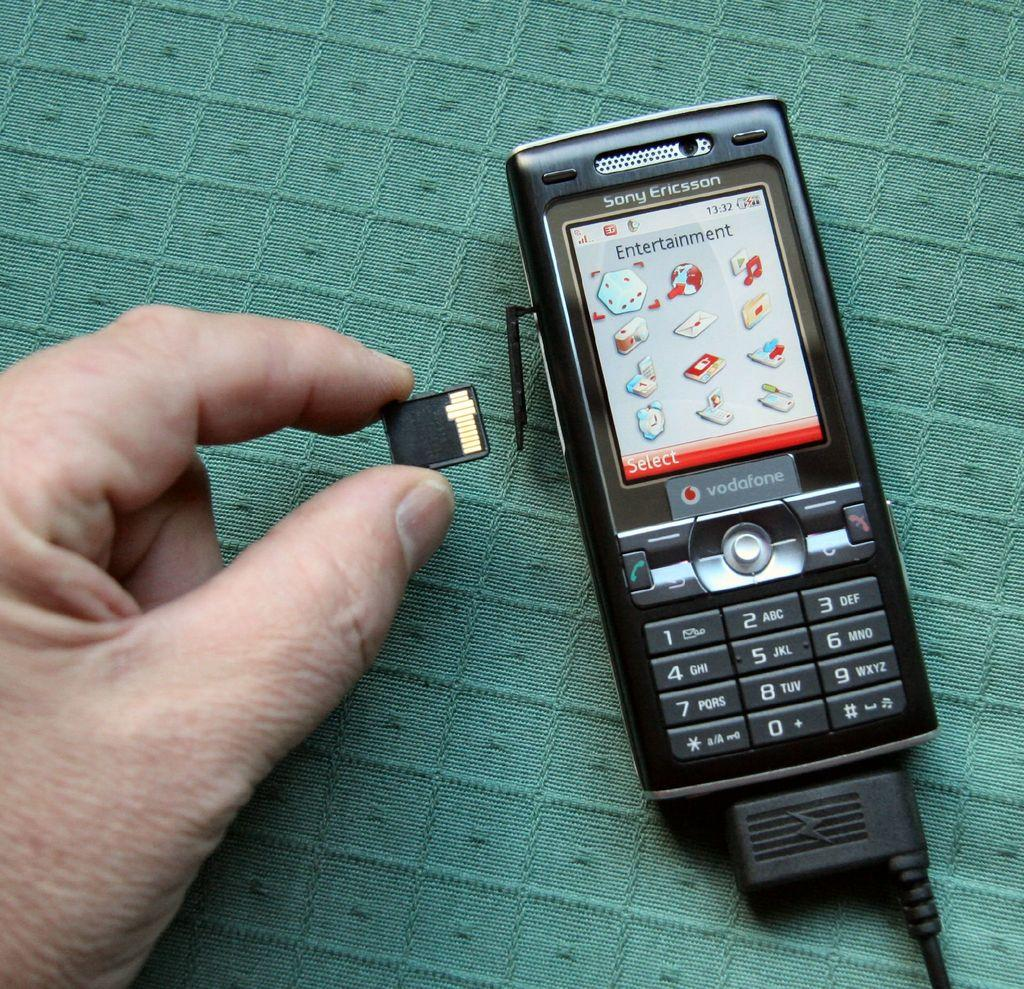<image>
Relay a brief, clear account of the picture shown. One particular mobile telephone is a Sony Ericcson vodafone. 